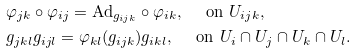<formula> <loc_0><loc_0><loc_500><loc_500>& \varphi _ { j k } \circ \varphi _ { i j } = \text {Ad} _ { g _ { i j k } } \circ \varphi _ { i k } , \quad \text { on } U _ { i j k } , \\ & g _ { j k l } g _ { i j l } = \varphi _ { k l } ( g _ { i j k } ) g _ { i k l } , \quad \text { on } U _ { i } \cap U _ { j } \cap U _ { k } \cap U _ { l } .</formula> 